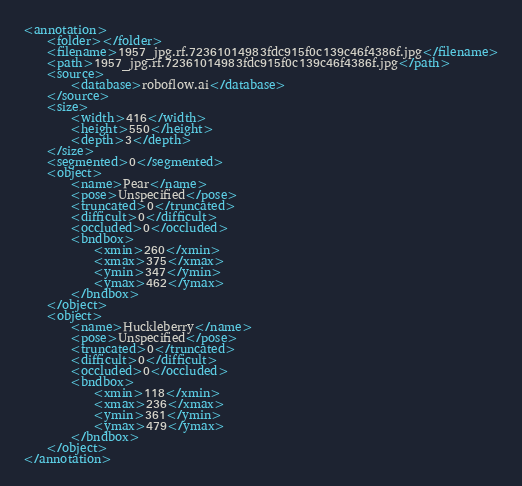Convert code to text. <code><loc_0><loc_0><loc_500><loc_500><_XML_><annotation>
	<folder></folder>
	<filename>1957_jpg.rf.72361014983fdc915f0c139c46f4386f.jpg</filename>
	<path>1957_jpg.rf.72361014983fdc915f0c139c46f4386f.jpg</path>
	<source>
		<database>roboflow.ai</database>
	</source>
	<size>
		<width>416</width>
		<height>550</height>
		<depth>3</depth>
	</size>
	<segmented>0</segmented>
	<object>
		<name>Pear</name>
		<pose>Unspecified</pose>
		<truncated>0</truncated>
		<difficult>0</difficult>
		<occluded>0</occluded>
		<bndbox>
			<xmin>260</xmin>
			<xmax>375</xmax>
			<ymin>347</ymin>
			<ymax>462</ymax>
		</bndbox>
	</object>
	<object>
		<name>Huckleberry</name>
		<pose>Unspecified</pose>
		<truncated>0</truncated>
		<difficult>0</difficult>
		<occluded>0</occluded>
		<bndbox>
			<xmin>118</xmin>
			<xmax>236</xmax>
			<ymin>361</ymin>
			<ymax>479</ymax>
		</bndbox>
	</object>
</annotation>
</code> 